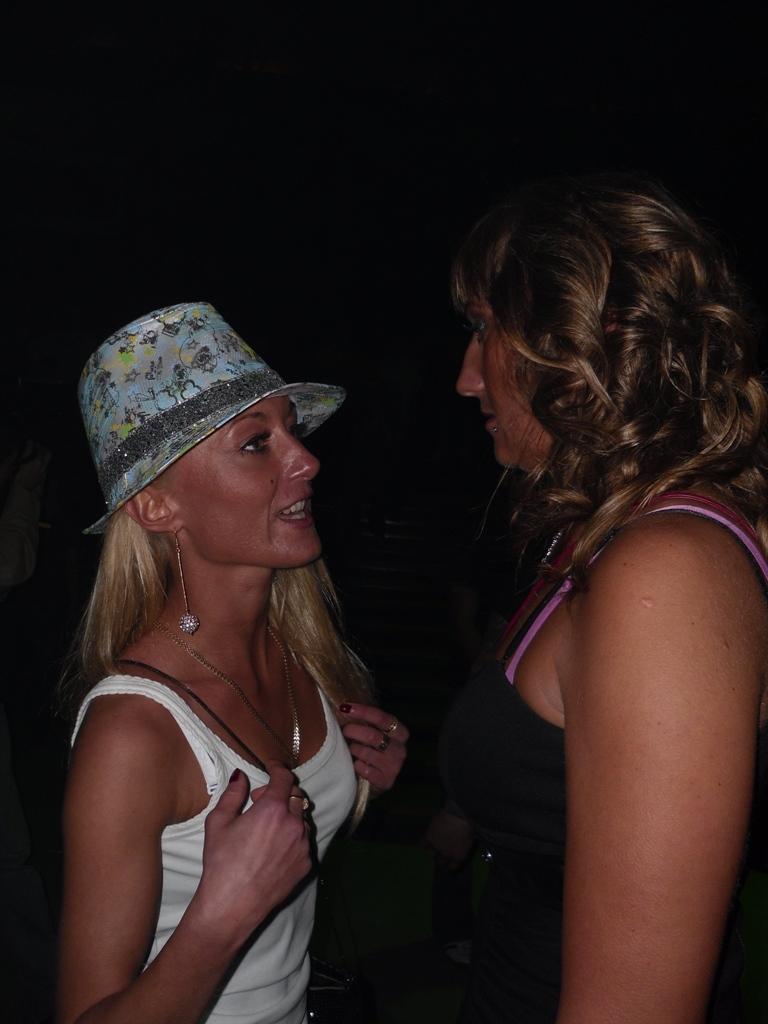In one or two sentences, can you explain what this image depicts? 2 people are standing and talking to each other. The person at the right is wearing a black dress. The person at the left is wearing a hat and a white t shirt. Behind them there is a black background. 